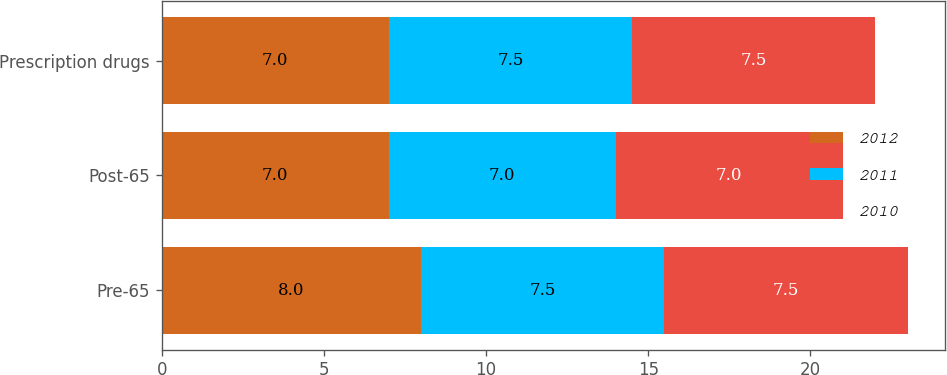<chart> <loc_0><loc_0><loc_500><loc_500><stacked_bar_chart><ecel><fcel>Pre-65<fcel>Post-65<fcel>Prescription drugs<nl><fcel>2012<fcel>8<fcel>7<fcel>7<nl><fcel>2011<fcel>7.5<fcel>7<fcel>7.5<nl><fcel>2010<fcel>7.5<fcel>7<fcel>7.5<nl></chart> 